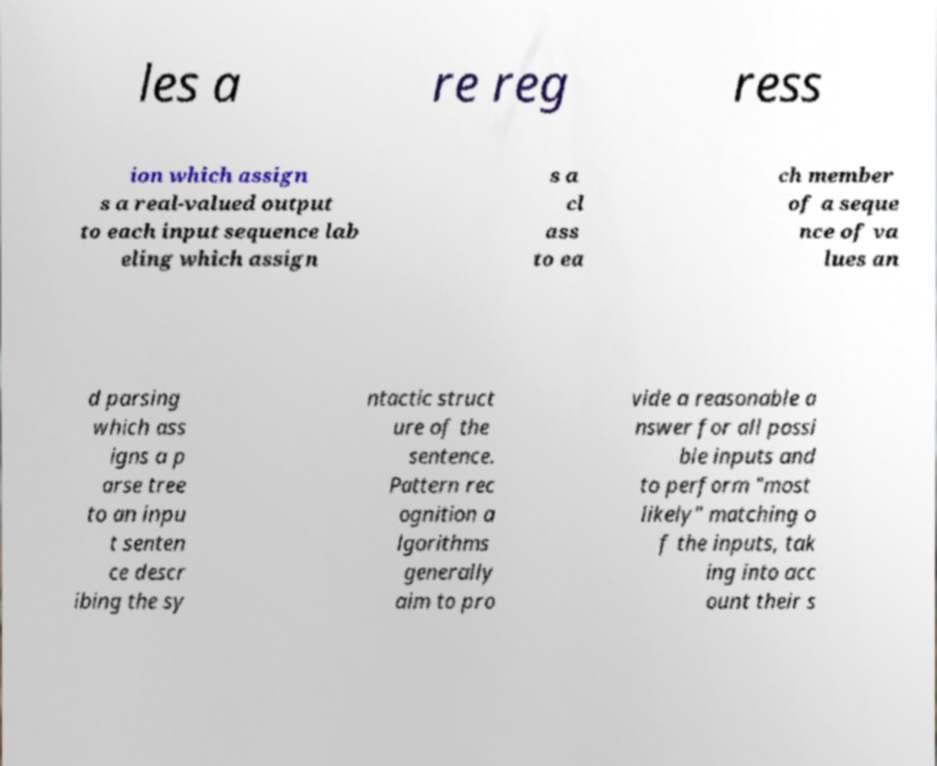Can you read and provide the text displayed in the image?This photo seems to have some interesting text. Can you extract and type it out for me? les a re reg ress ion which assign s a real-valued output to each input sequence lab eling which assign s a cl ass to ea ch member of a seque nce of va lues an d parsing which ass igns a p arse tree to an inpu t senten ce descr ibing the sy ntactic struct ure of the sentence. Pattern rec ognition a lgorithms generally aim to pro vide a reasonable a nswer for all possi ble inputs and to perform "most likely" matching o f the inputs, tak ing into acc ount their s 